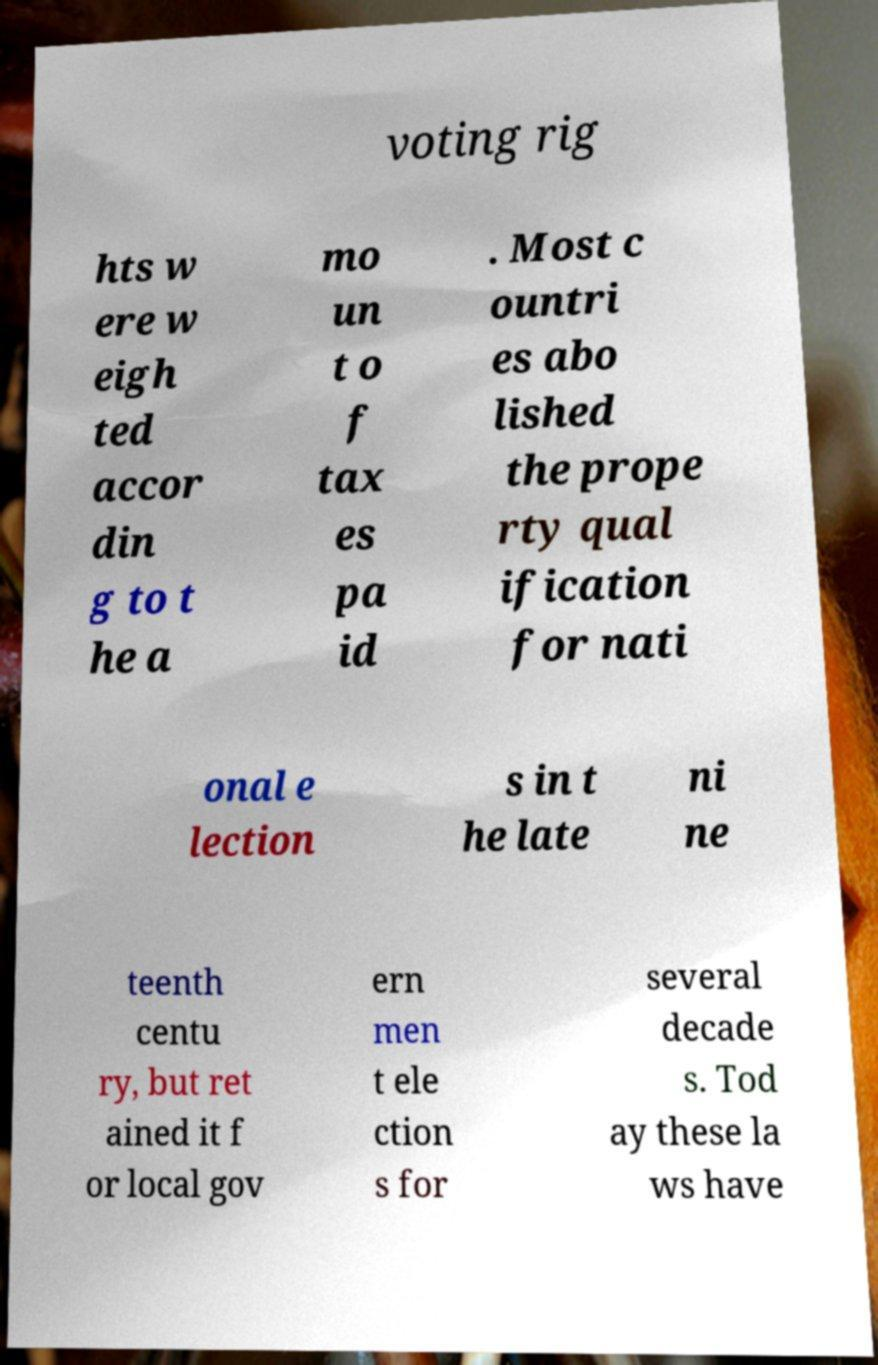Can you read and provide the text displayed in the image?This photo seems to have some interesting text. Can you extract and type it out for me? voting rig hts w ere w eigh ted accor din g to t he a mo un t o f tax es pa id . Most c ountri es abo lished the prope rty qual ification for nati onal e lection s in t he late ni ne teenth centu ry, but ret ained it f or local gov ern men t ele ction s for several decade s. Tod ay these la ws have 